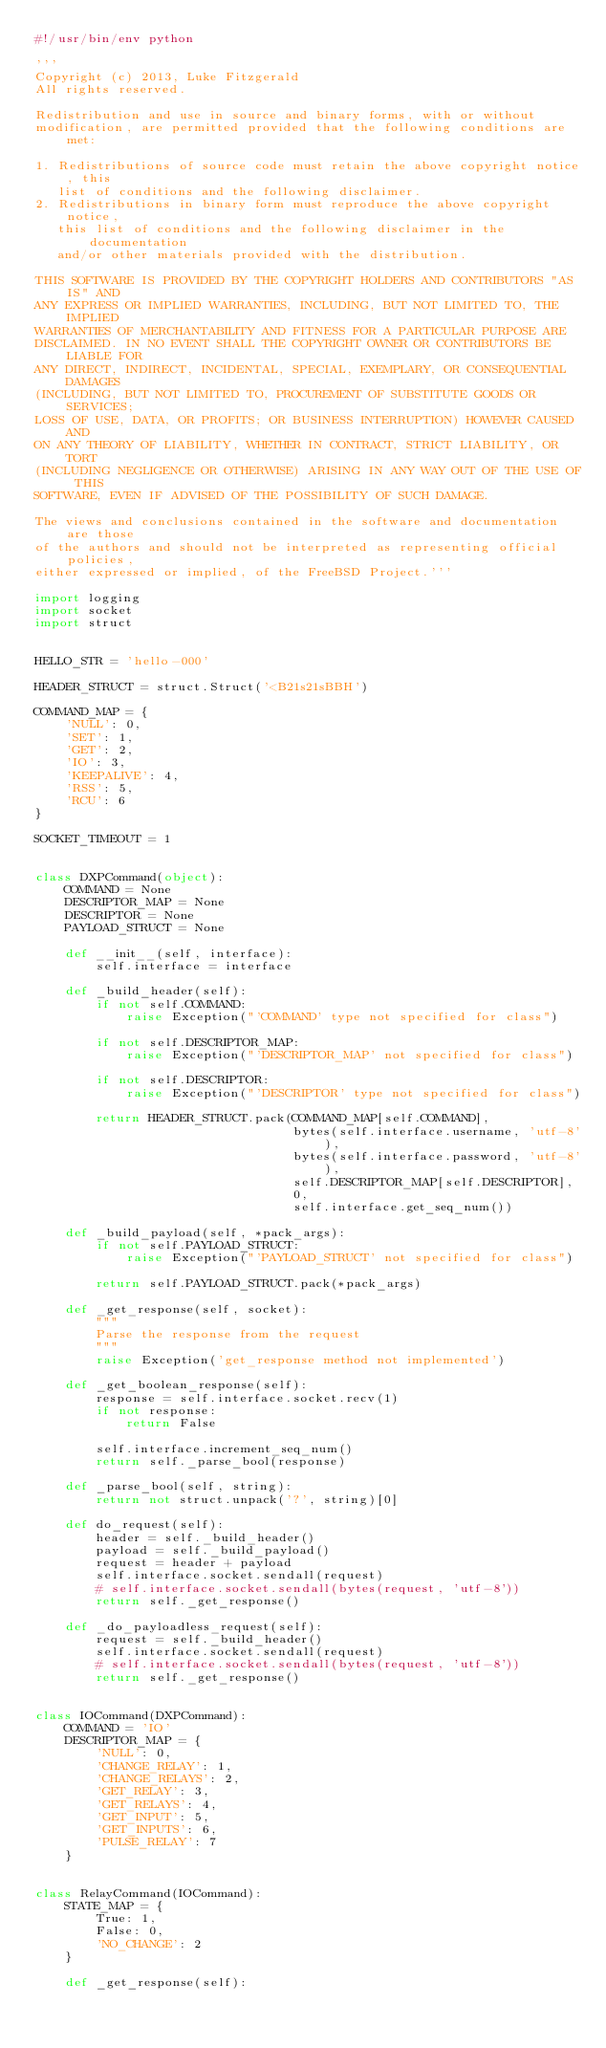Convert code to text. <code><loc_0><loc_0><loc_500><loc_500><_Python_>#!/usr/bin/env python

'''
Copyright (c) 2013, Luke Fitzgerald
All rights reserved.

Redistribution and use in source and binary forms, with or without
modification, are permitted provided that the following conditions are met:

1. Redistributions of source code must retain the above copyright notice, this
   list of conditions and the following disclaimer.
2. Redistributions in binary form must reproduce the above copyright notice,
   this list of conditions and the following disclaimer in the documentation
   and/or other materials provided with the distribution.

THIS SOFTWARE IS PROVIDED BY THE COPYRIGHT HOLDERS AND CONTRIBUTORS "AS IS" AND
ANY EXPRESS OR IMPLIED WARRANTIES, INCLUDING, BUT NOT LIMITED TO, THE IMPLIED
WARRANTIES OF MERCHANTABILITY AND FITNESS FOR A PARTICULAR PURPOSE ARE
DISCLAIMED. IN NO EVENT SHALL THE COPYRIGHT OWNER OR CONTRIBUTORS BE LIABLE FOR
ANY DIRECT, INDIRECT, INCIDENTAL, SPECIAL, EXEMPLARY, OR CONSEQUENTIAL DAMAGES
(INCLUDING, BUT NOT LIMITED TO, PROCUREMENT OF SUBSTITUTE GOODS OR SERVICES;
LOSS OF USE, DATA, OR PROFITS; OR BUSINESS INTERRUPTION) HOWEVER CAUSED AND
ON ANY THEORY OF LIABILITY, WHETHER IN CONTRACT, STRICT LIABILITY, OR TORT
(INCLUDING NEGLIGENCE OR OTHERWISE) ARISING IN ANY WAY OUT OF THE USE OF THIS
SOFTWARE, EVEN IF ADVISED OF THE POSSIBILITY OF SUCH DAMAGE.

The views and conclusions contained in the software and documentation are those
of the authors and should not be interpreted as representing official policies,
either expressed or implied, of the FreeBSD Project.'''

import logging
import socket
import struct


HELLO_STR = 'hello-000'

HEADER_STRUCT = struct.Struct('<B21s21sBBH')

COMMAND_MAP = {
    'NULL': 0,
    'SET': 1,
    'GET': 2,
    'IO': 3,
    'KEEPALIVE': 4,
    'RSS': 5,
    'RCU': 6
}

SOCKET_TIMEOUT = 1


class DXPCommand(object):
    COMMAND = None
    DESCRIPTOR_MAP = None
    DESCRIPTOR = None
    PAYLOAD_STRUCT = None

    def __init__(self, interface):
        self.interface = interface

    def _build_header(self):
        if not self.COMMAND:
            raise Exception("'COMMAND' type not specified for class")

        if not self.DESCRIPTOR_MAP:
            raise Exception("'DESCRIPTOR_MAP' not specified for class")

        if not self.DESCRIPTOR:
            raise Exception("'DESCRIPTOR' type not specified for class")

        return HEADER_STRUCT.pack(COMMAND_MAP[self.COMMAND],
                                  bytes(self.interface.username, 'utf-8'),
                                  bytes(self.interface.password, 'utf-8'),
                                  self.DESCRIPTOR_MAP[self.DESCRIPTOR],
                                  0,
                                  self.interface.get_seq_num())

    def _build_payload(self, *pack_args):
        if not self.PAYLOAD_STRUCT:
            raise Exception("'PAYLOAD_STRUCT' not specified for class")

        return self.PAYLOAD_STRUCT.pack(*pack_args)

    def _get_response(self, socket):
        """
        Parse the response from the request
        """
        raise Exception('get_response method not implemented')

    def _get_boolean_response(self):
        response = self.interface.socket.recv(1)
        if not response:
            return False

        self.interface.increment_seq_num()
        return self._parse_bool(response)

    def _parse_bool(self, string):
        return not struct.unpack('?', string)[0]

    def do_request(self):
        header = self._build_header()
        payload = self._build_payload()
        request = header + payload
        self.interface.socket.sendall(request)
        # self.interface.socket.sendall(bytes(request, 'utf-8'))
        return self._get_response()

    def _do_payloadless_request(self):
        request = self._build_header()
        self.interface.socket.sendall(request)
        # self.interface.socket.sendall(bytes(request, 'utf-8'))
        return self._get_response()


class IOCommand(DXPCommand):
    COMMAND = 'IO'
    DESCRIPTOR_MAP = {
        'NULL': 0,
        'CHANGE_RELAY': 1,
        'CHANGE_RELAYS': 2,
        'GET_RELAY': 3,
        'GET_RELAYS': 4,
        'GET_INPUT': 5,
        'GET_INPUTS': 6,
        'PULSE_RELAY': 7
    }


class RelayCommand(IOCommand):
    STATE_MAP = {
        True: 1,
        False: 0,
        'NO_CHANGE': 2
    }

    def _get_response(self):</code> 